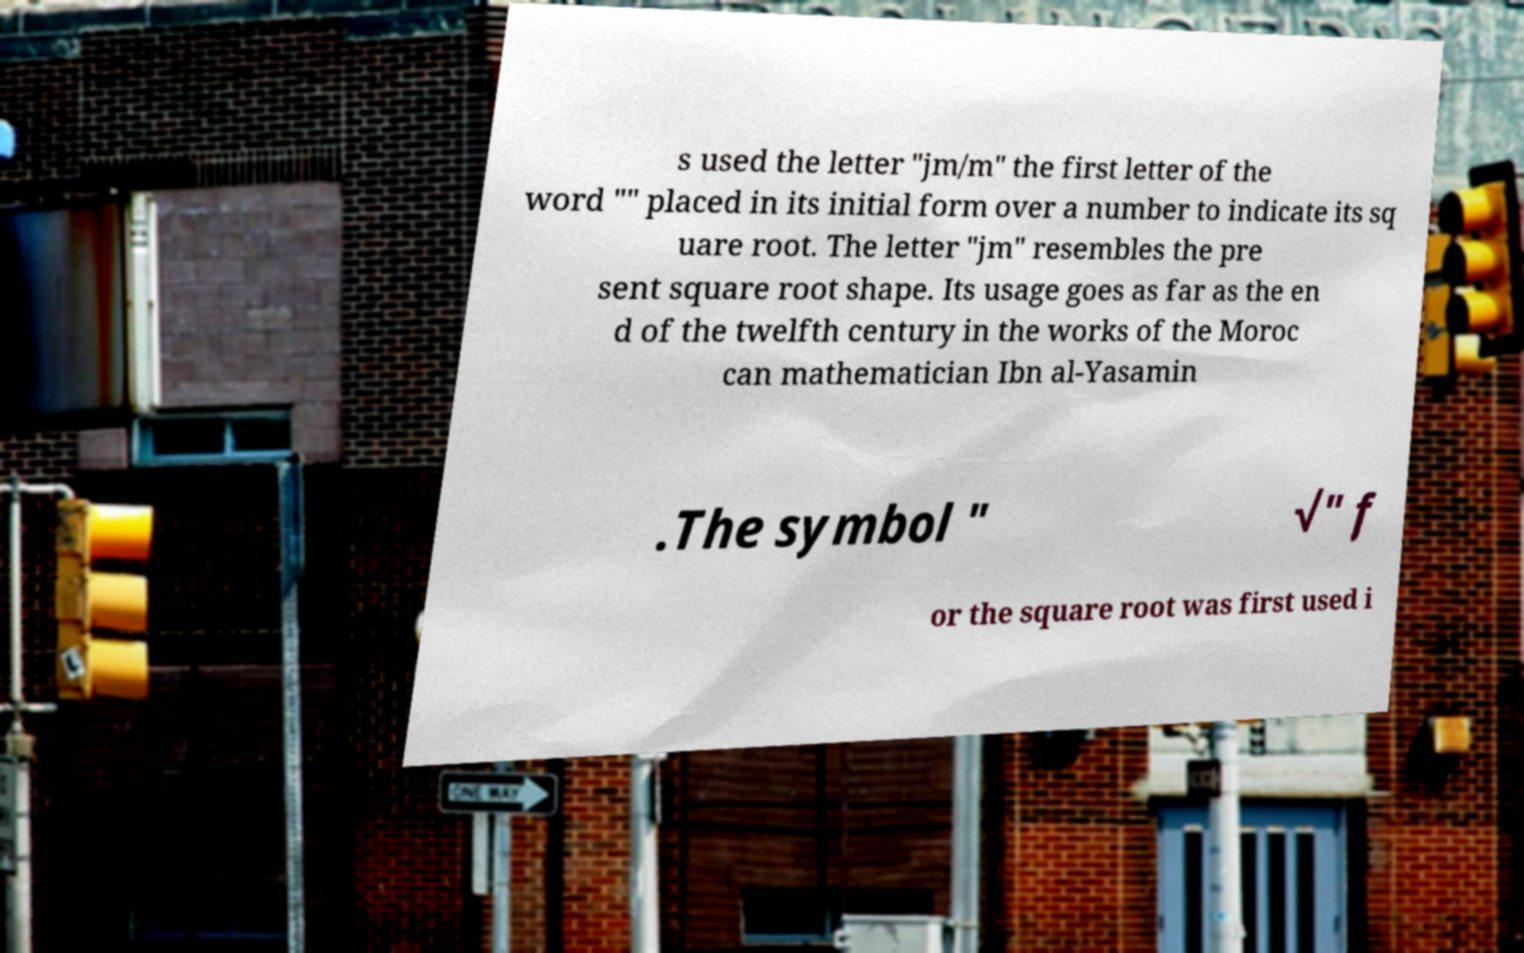There's text embedded in this image that I need extracted. Can you transcribe it verbatim? s used the letter "jm/m" the first letter of the word "" placed in its initial form over a number to indicate its sq uare root. The letter "jm" resembles the pre sent square root shape. Its usage goes as far as the en d of the twelfth century in the works of the Moroc can mathematician Ibn al-Yasamin .The symbol " √" f or the square root was first used i 